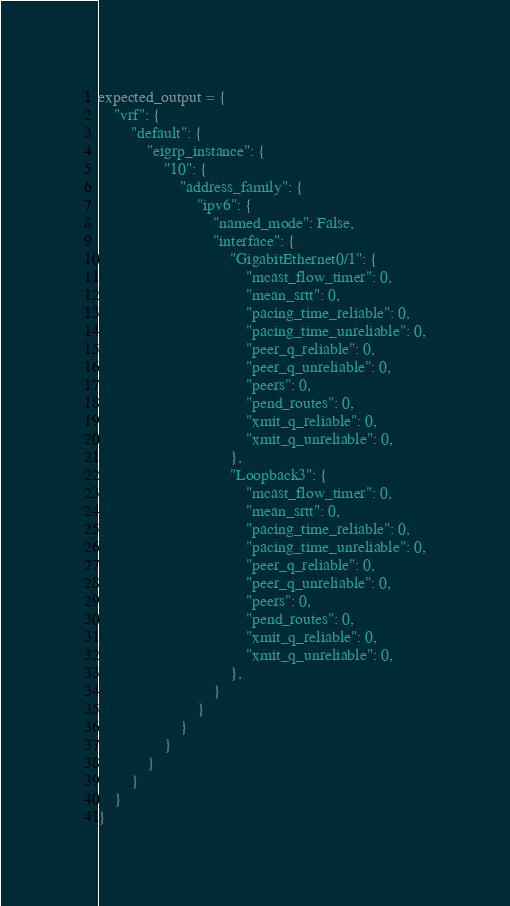Convert code to text. <code><loc_0><loc_0><loc_500><loc_500><_Python_>expected_output = {
    "vrf": {
        "default": {
            "eigrp_instance": {
                "10": {
                    "address_family": {
                        "ipv6": {
                            "named_mode": False,
                            "interface": {
                                "GigabitEthernet0/1": {
                                    "mcast_flow_timer": 0,
                                    "mean_srtt": 0,
                                    "pacing_time_reliable": 0,
                                    "pacing_time_unreliable": 0,
                                    "peer_q_reliable": 0,
                                    "peer_q_unreliable": 0,
                                    "peers": 0,
                                    "pend_routes": 0,
                                    "xmit_q_reliable": 0,
                                    "xmit_q_unreliable": 0,
                                },
                                "Loopback3": {
                                    "mcast_flow_timer": 0,
                                    "mean_srtt": 0,
                                    "pacing_time_reliable": 0,
                                    "pacing_time_unreliable": 0,
                                    "peer_q_reliable": 0,
                                    "peer_q_unreliable": 0,
                                    "peers": 0,
                                    "pend_routes": 0,
                                    "xmit_q_reliable": 0,
                                    "xmit_q_unreliable": 0,
                                },
                            }
                        }
                    }
                }
            }
        }
    }
}

</code> 